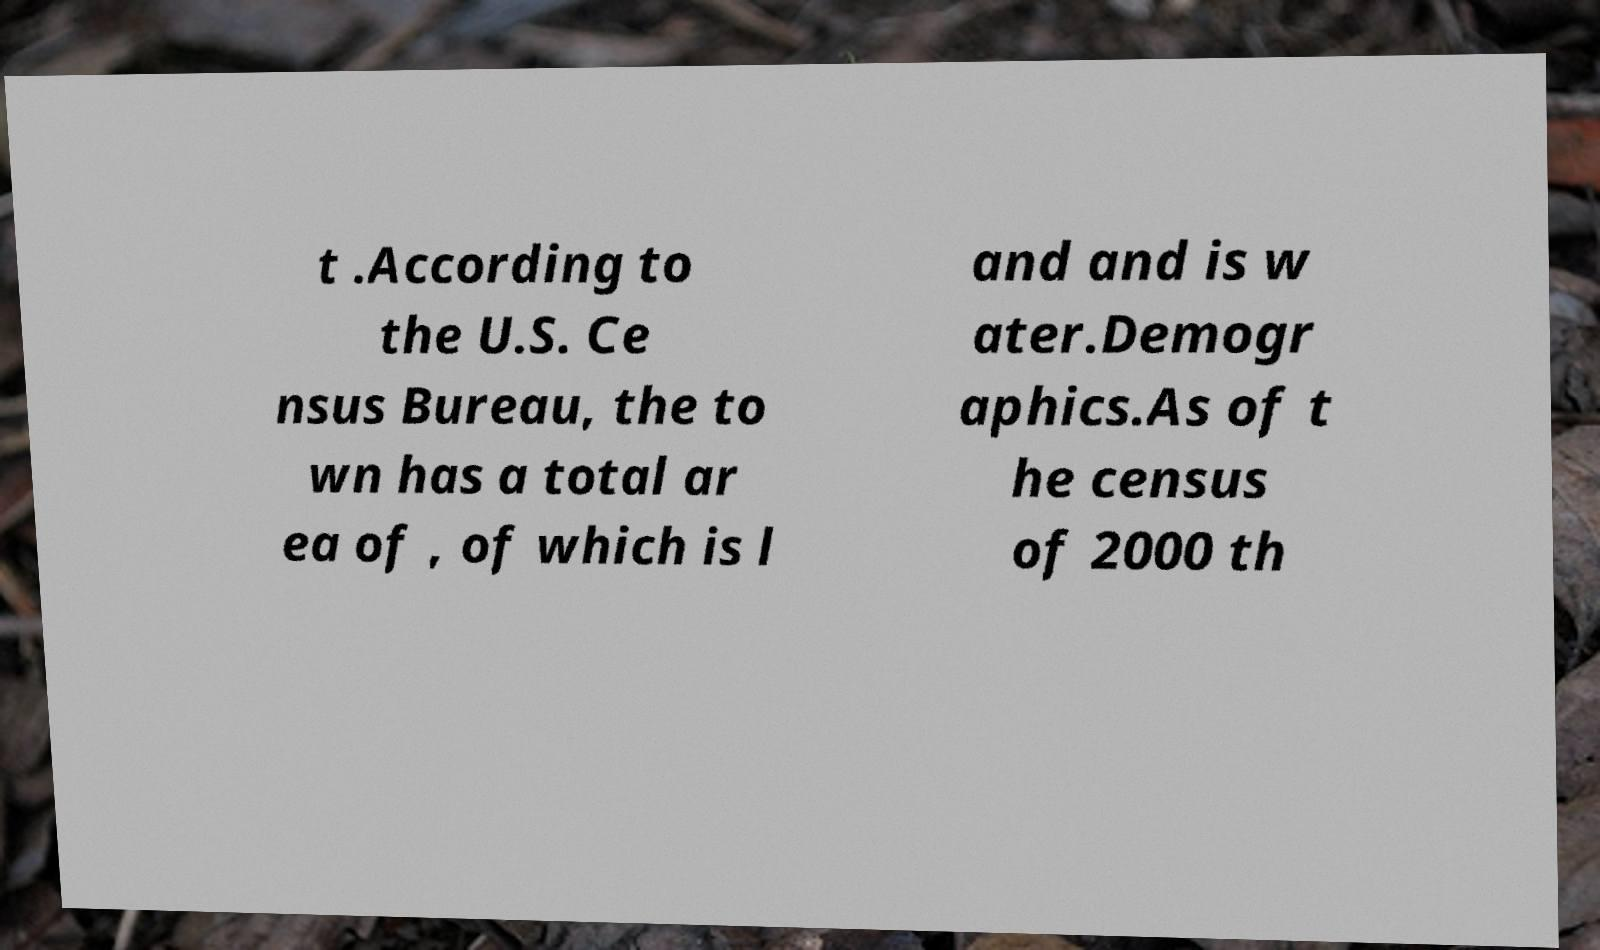Can you read and provide the text displayed in the image?This photo seems to have some interesting text. Can you extract and type it out for me? t .According to the U.S. Ce nsus Bureau, the to wn has a total ar ea of , of which is l and and is w ater.Demogr aphics.As of t he census of 2000 th 